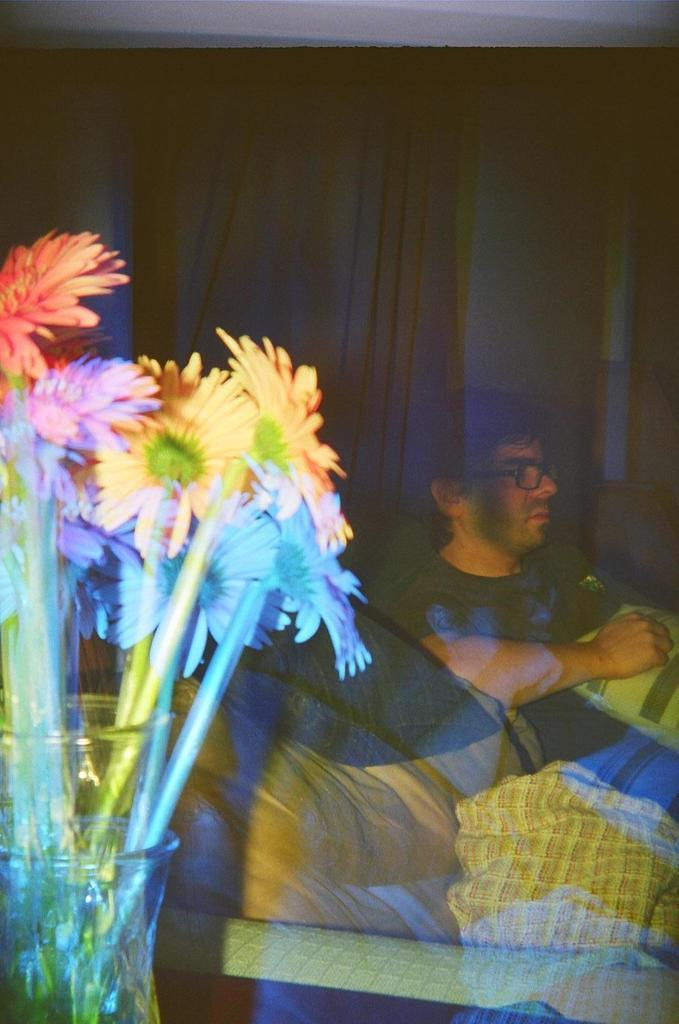What type of plants can be seen in the image? There are flowers in the image. What part of the flowers is visible in the image? There are stems in the image. What material are some of the objects made of in the image? There are glass objects in the image. Who or what is present in the image? There is a person in the image. What type of furniture is visible in the image? There is a pillow in the image. Can you describe any other objects in the image? There are other objects in the image, but their specific details are not mentioned in the provided facts. What type of brush can be seen cleaning the toad in the image? There is no brush or toad present in the image. 